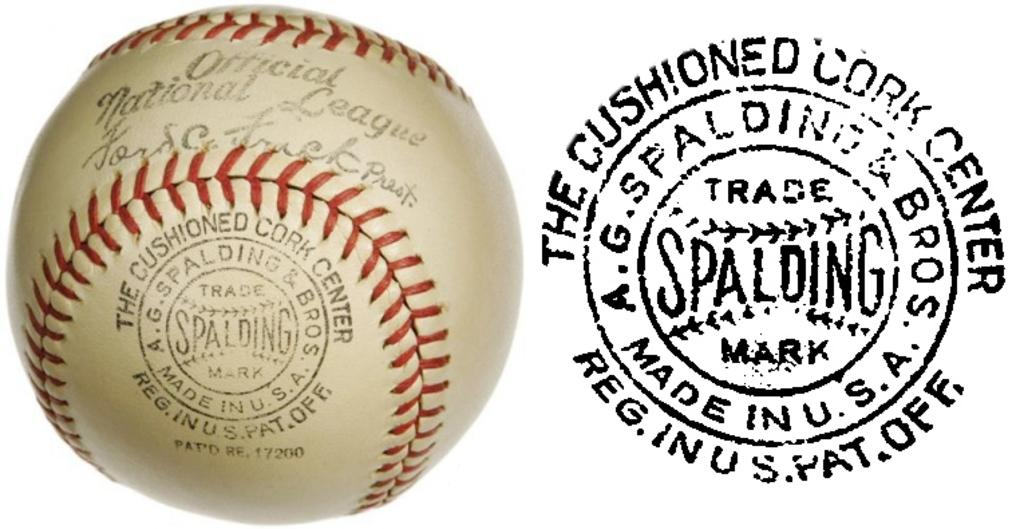<image>
Offer a succinct explanation of the picture presented. A Spalding Baseball is stamped Official National League and is shown next to an image of the stamp that says The Cushioned Cork Center. 